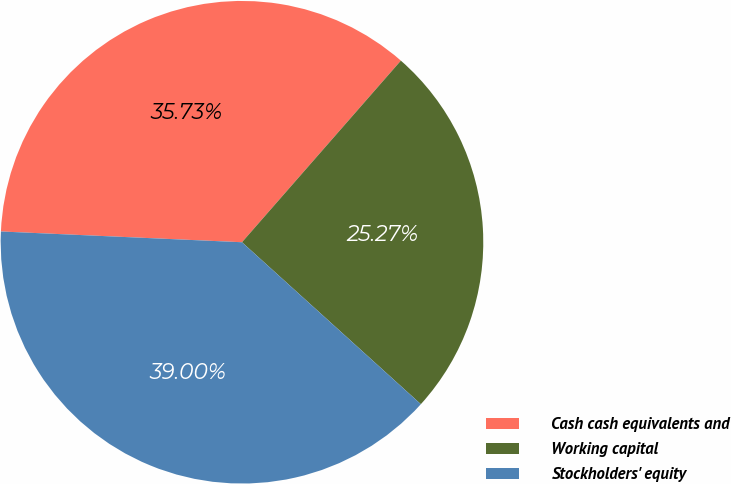Convert chart. <chart><loc_0><loc_0><loc_500><loc_500><pie_chart><fcel>Cash cash equivalents and<fcel>Working capital<fcel>Stockholders' equity<nl><fcel>35.73%<fcel>25.27%<fcel>39.0%<nl></chart> 